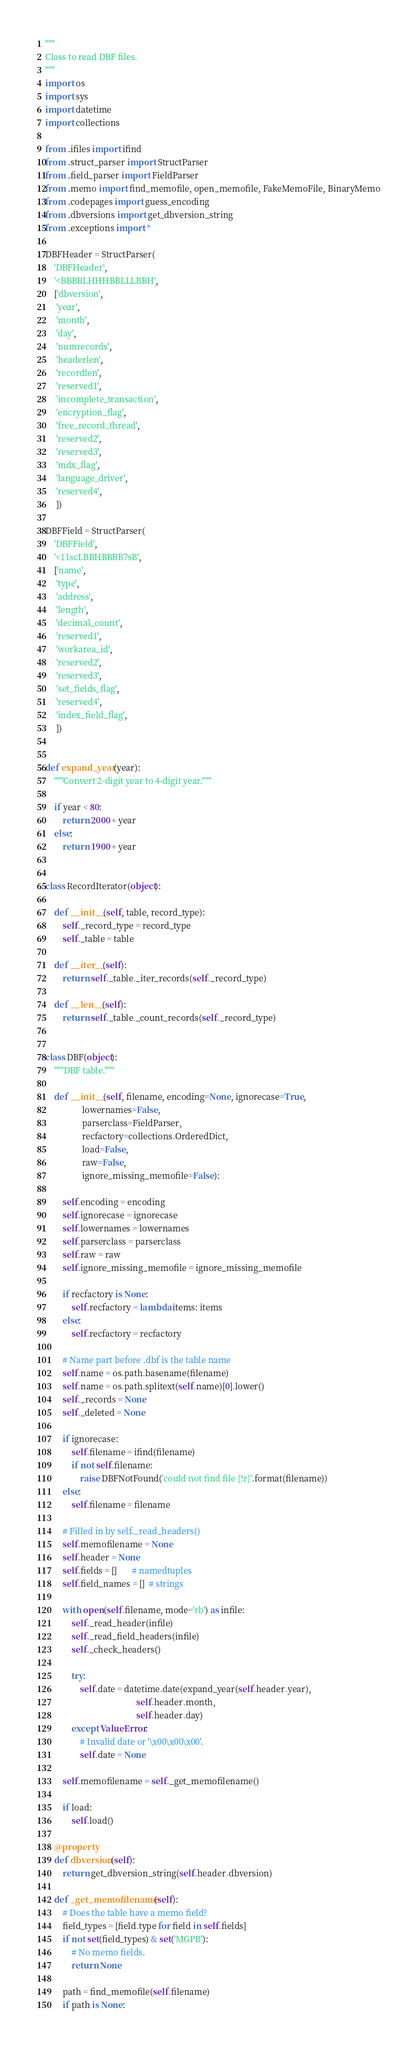<code> <loc_0><loc_0><loc_500><loc_500><_Python_>"""
Class to read DBF files.
"""
import os
import sys
import datetime
import collections

from .ifiles import ifind
from .struct_parser import StructParser
from .field_parser import FieldParser
from .memo import find_memofile, open_memofile, FakeMemoFile, BinaryMemo
from .codepages import guess_encoding
from .dbversions import get_dbversion_string
from .exceptions import *

DBFHeader = StructParser(
    'DBFHeader',
    '<BBBBLHHHBBLLLBBH',
    ['dbversion',
     'year',
     'month',
     'day',
     'numrecords',
     'headerlen',
     'recordlen',
     'reserved1',
     'incomplete_transaction',
     'encryption_flag',
     'free_record_thread',
     'reserved2',
     'reserved3',
     'mdx_flag',
     'language_driver',
     'reserved4',
     ])

DBFField = StructParser(
    'DBFField',
    '<11scLBBHBBBB7sB',
    ['name',
     'type',
     'address',
     'length',
     'decimal_count',
     'reserved1',
     'workarea_id',
     'reserved2',
     'reserved3',
     'set_fields_flag',
     'reserved4',
     'index_field_flag',
     ])


def expand_year(year):
    """Convert 2-digit year to 4-digit year."""

    if year < 80:
        return 2000 + year
    else:
        return 1900 + year


class RecordIterator(object):

    def __init__(self, table, record_type):
        self._record_type = record_type
        self._table = table

    def __iter__(self):
        return self._table._iter_records(self._record_type)

    def __len__(self):
        return self._table._count_records(self._record_type)


class DBF(object):
    """DBF table."""

    def __init__(self, filename, encoding=None, ignorecase=True,
                 lowernames=False,
                 parserclass=FieldParser,
                 recfactory=collections.OrderedDict,
                 load=False,
                 raw=False,
                 ignore_missing_memofile=False):

        self.encoding = encoding
        self.ignorecase = ignorecase
        self.lowernames = lowernames
        self.parserclass = parserclass
        self.raw = raw
        self.ignore_missing_memofile = ignore_missing_memofile

        if recfactory is None:
            self.recfactory = lambda items: items
        else:
            self.recfactory = recfactory

        # Name part before .dbf is the table name
        self.name = os.path.basename(filename)
        self.name = os.path.splitext(self.name)[0].lower()
        self._records = None
        self._deleted = None

        if ignorecase:
            self.filename = ifind(filename)
            if not self.filename:
                raise DBFNotFound('could not find file {!r}'.format(filename))
        else:
            self.filename = filename

        # Filled in by self._read_headers()
        self.memofilename = None
        self.header = None
        self.fields = []       # namedtuples
        self.field_names = []  # strings

        with open(self.filename, mode='rb') as infile:
            self._read_header(infile)
            self._read_field_headers(infile)
            self._check_headers()

            try:
                self.date = datetime.date(expand_year(self.header.year),
                                          self.header.month,
                                          self.header.day)
            except ValueError:
                # Invalid date or '\x00\x00\x00'.
                self.date = None

        self.memofilename = self._get_memofilename()

        if load:
            self.load()

    @property
    def dbversion(self):
        return get_dbversion_string(self.header.dbversion)

    def _get_memofilename(self):
        # Does the table have a memo field?
        field_types = [field.type for field in self.fields]
        if not set(field_types) & set('MGPB'):
            # No memo fields.
            return None

        path = find_memofile(self.filename)
        if path is None:</code> 